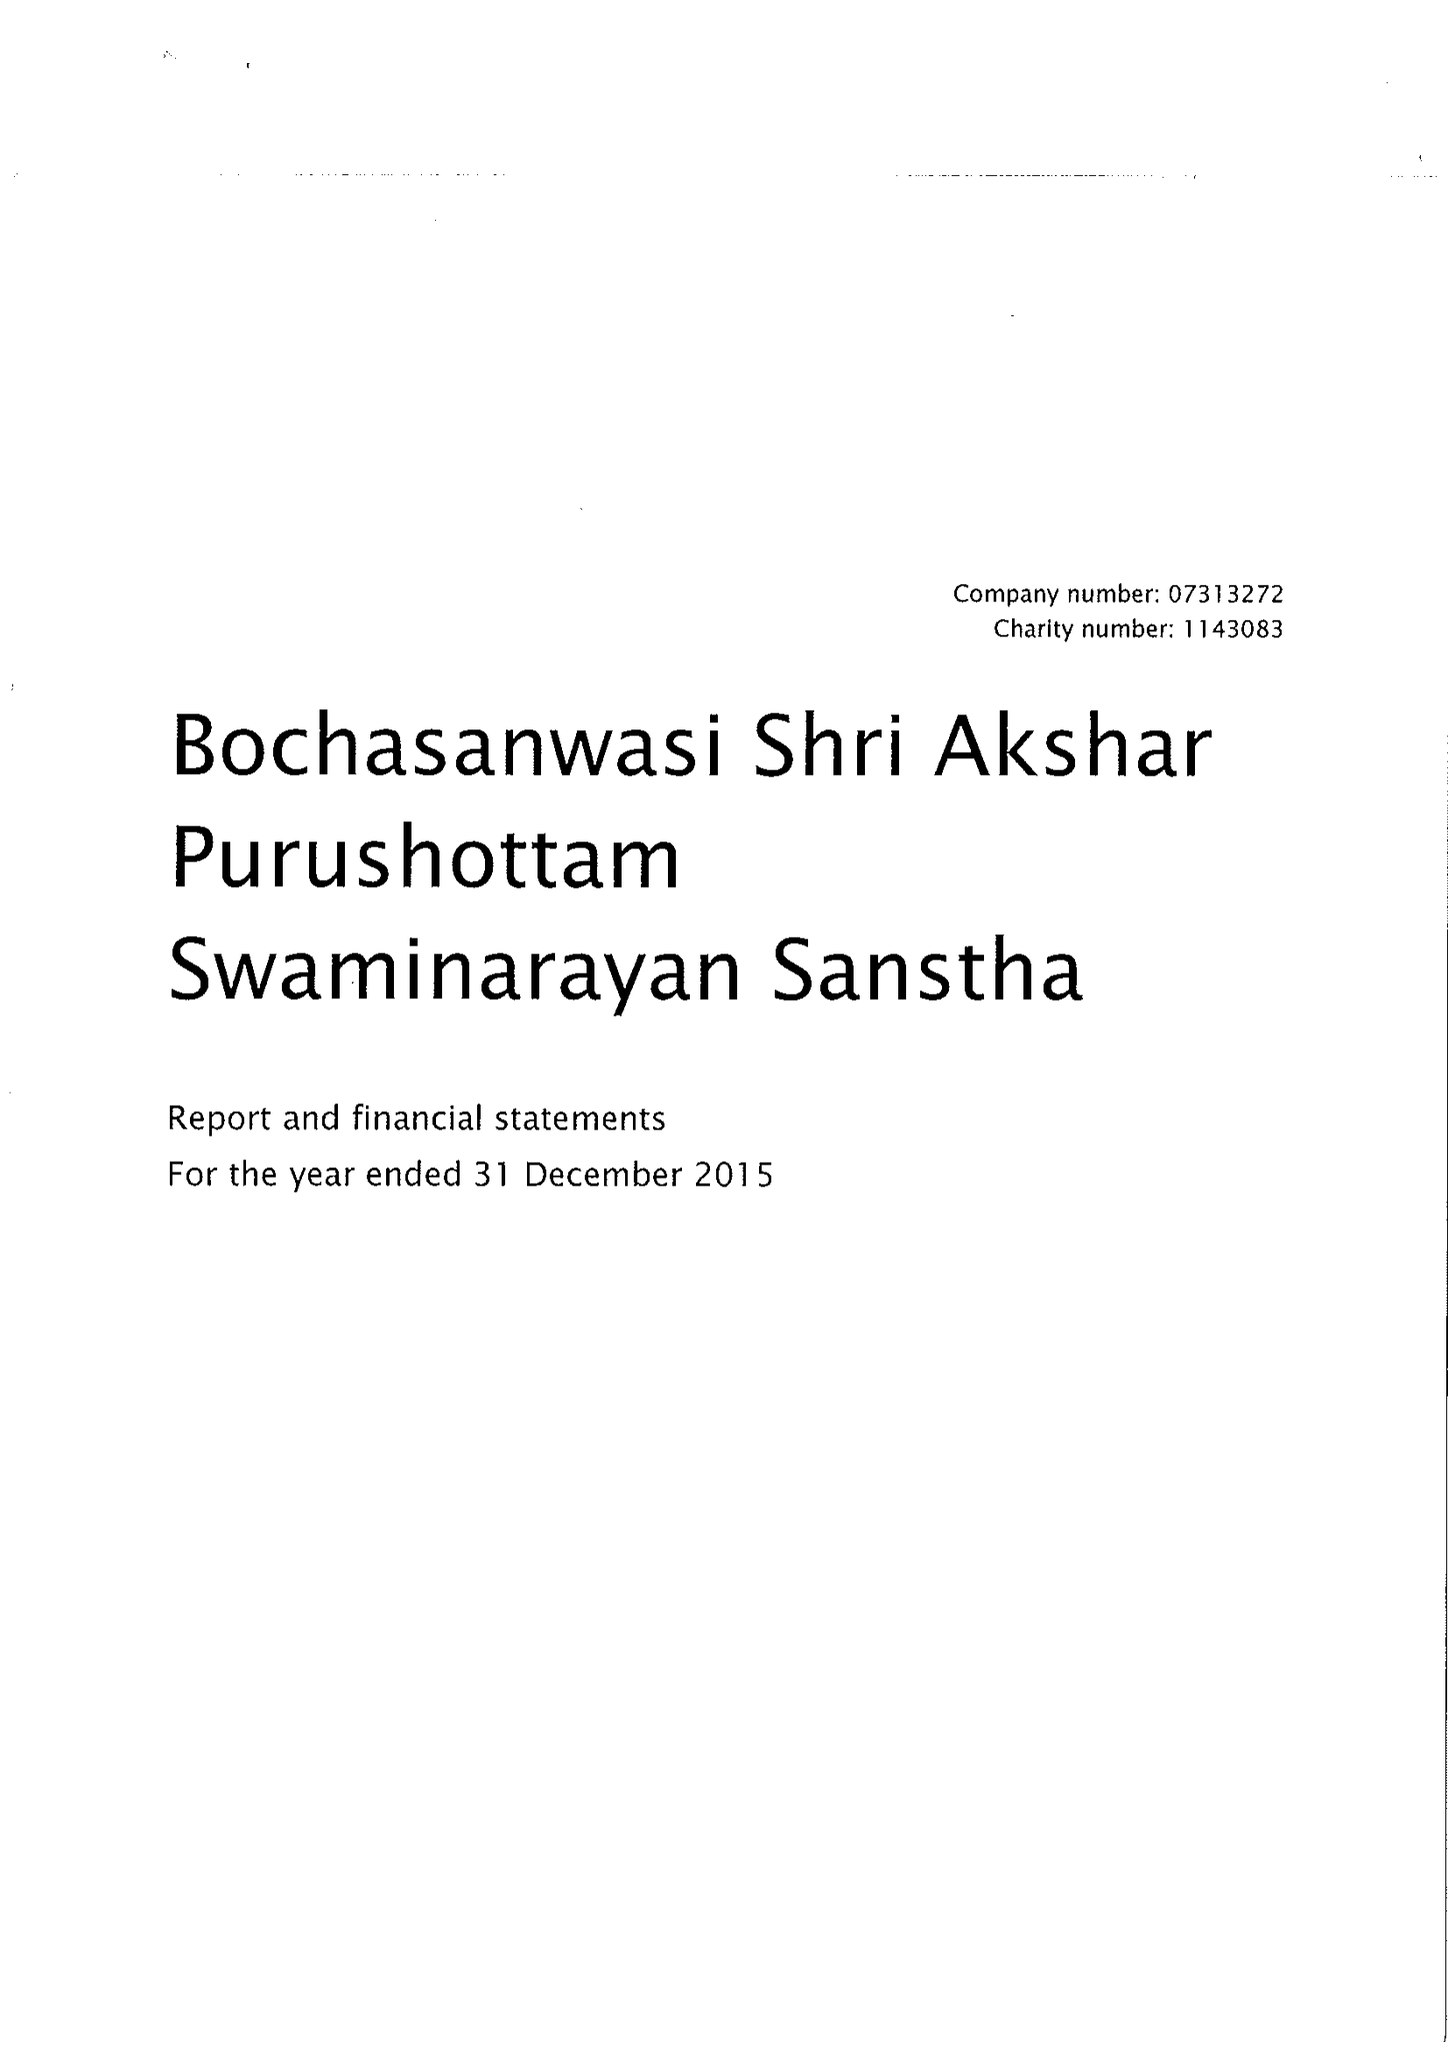What is the value for the charity_name?
Answer the question using a single word or phrase. Bochasanwasi Shri Akshar Purushottam Swaminarayan Sanstha 